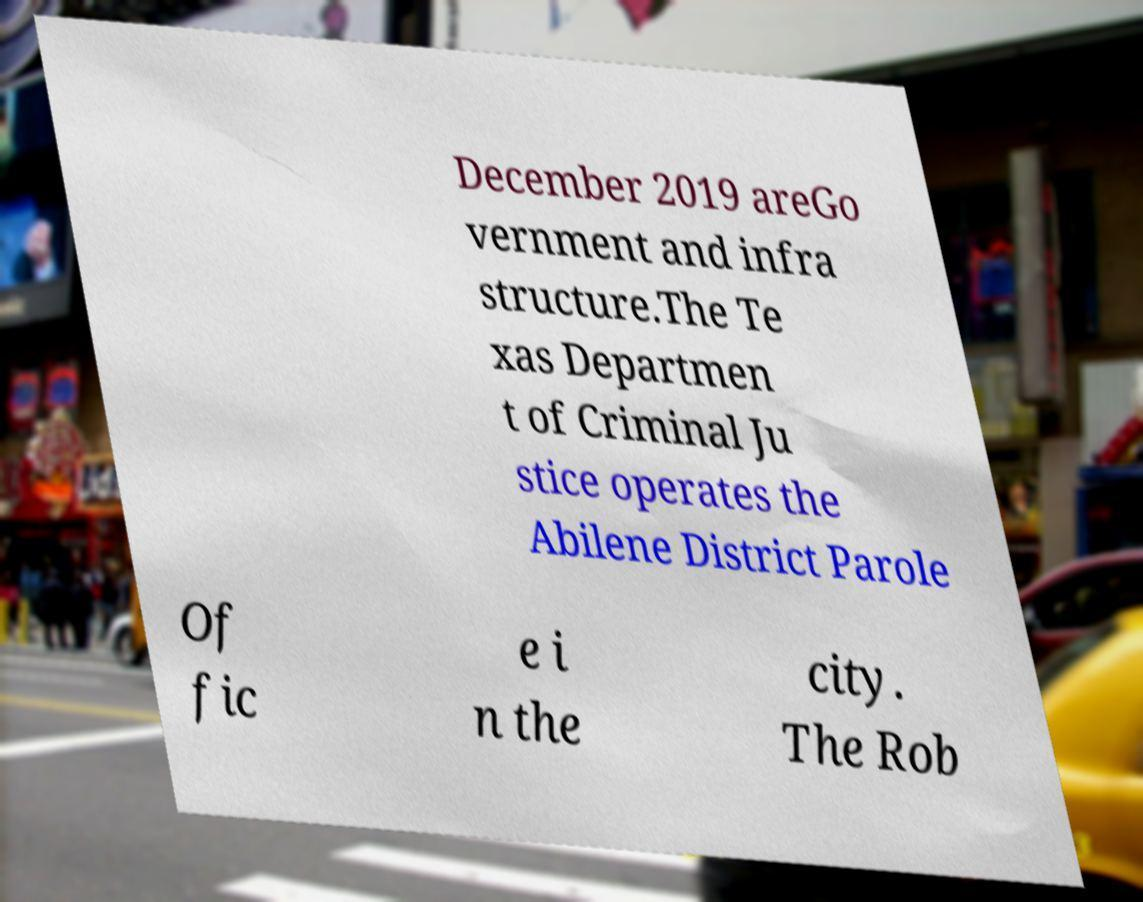Please read and relay the text visible in this image. What does it say? December 2019 areGo vernment and infra structure.The Te xas Departmen t of Criminal Ju stice operates the Abilene District Parole Of fic e i n the city. The Rob 